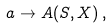<formula> <loc_0><loc_0><loc_500><loc_500>a \to A ( S , X ) \, ,</formula> 